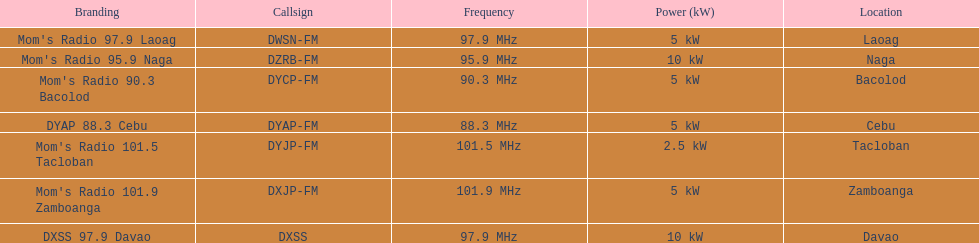What is the only radio station with a frequency below 90 mhz? DYAP 88.3 Cebu. 